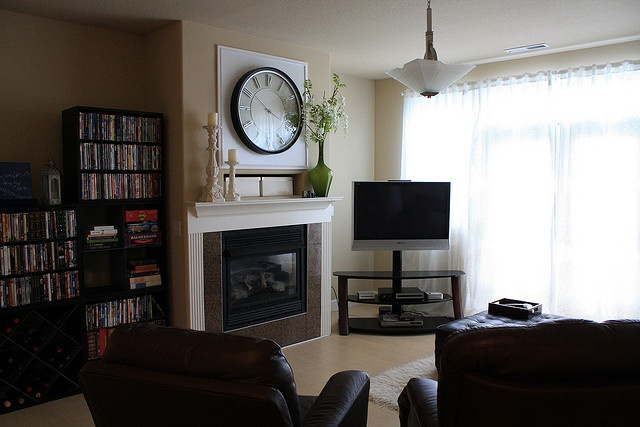Describe the objects in this image and their specific colors. I can see book in black, maroon, and gray tones, couch in black, gray, and darkgray tones, chair in black and gray tones, tv in black, gray, and white tones, and clock in black, darkgray, lightblue, and gray tones in this image. 